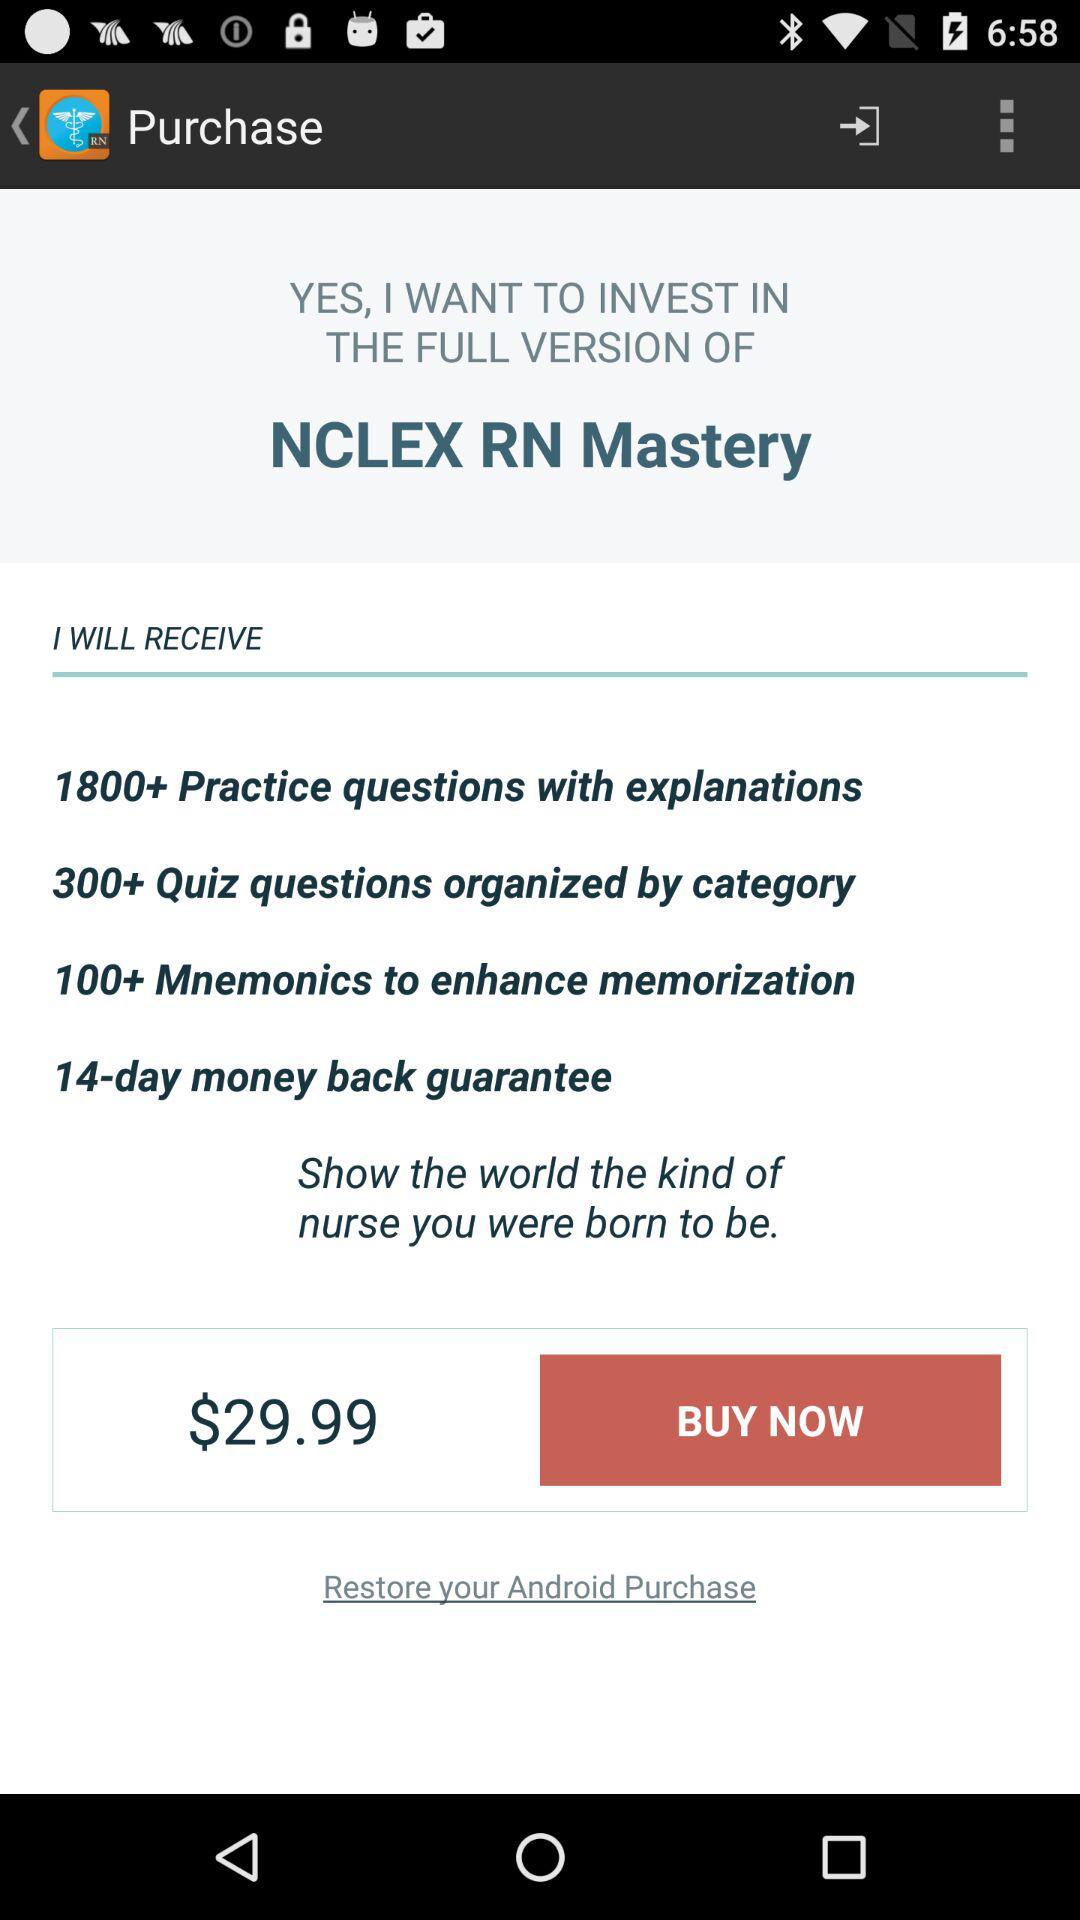How many practice questions are included with the full version?
Answer the question using a single word or phrase. 1800+ 